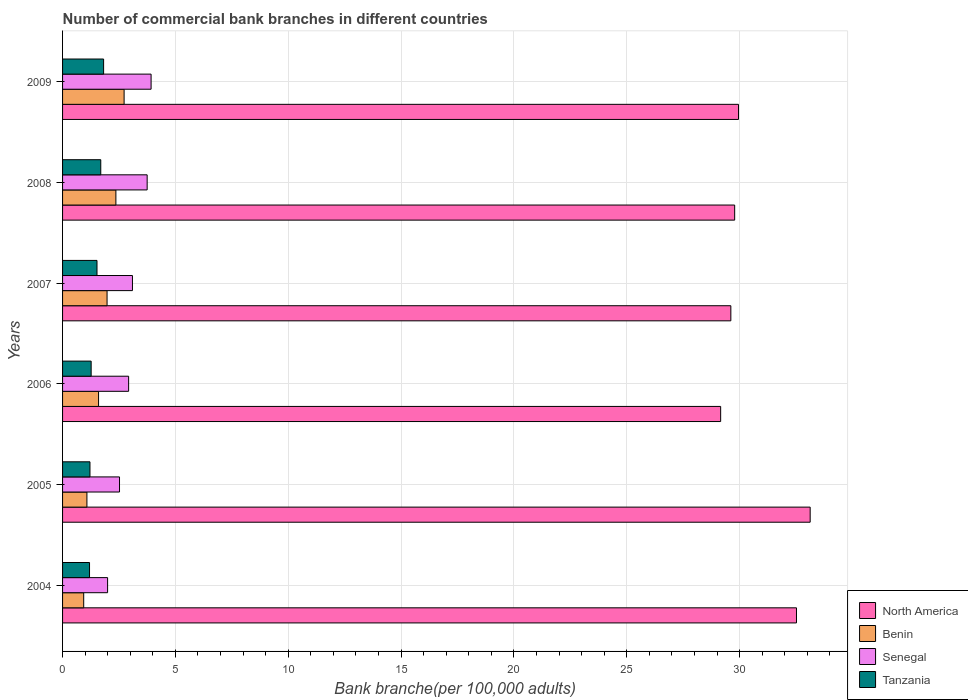Are the number of bars on each tick of the Y-axis equal?
Provide a succinct answer. Yes. How many bars are there on the 4th tick from the top?
Ensure brevity in your answer.  4. How many bars are there on the 3rd tick from the bottom?
Offer a very short reply. 4. What is the label of the 2nd group of bars from the top?
Make the answer very short. 2008. In how many cases, is the number of bars for a given year not equal to the number of legend labels?
Your answer should be very brief. 0. What is the number of commercial bank branches in Tanzania in 2008?
Provide a succinct answer. 1.69. Across all years, what is the maximum number of commercial bank branches in Benin?
Keep it short and to the point. 2.73. Across all years, what is the minimum number of commercial bank branches in Tanzania?
Keep it short and to the point. 1.2. In which year was the number of commercial bank branches in Benin minimum?
Your answer should be very brief. 2004. What is the total number of commercial bank branches in Benin in the graph?
Your answer should be compact. 10.67. What is the difference between the number of commercial bank branches in Benin in 2006 and that in 2009?
Your answer should be compact. -1.13. What is the difference between the number of commercial bank branches in Senegal in 2005 and the number of commercial bank branches in North America in 2008?
Offer a very short reply. -27.26. What is the average number of commercial bank branches in Tanzania per year?
Offer a very short reply. 1.45. In the year 2009, what is the difference between the number of commercial bank branches in Tanzania and number of commercial bank branches in North America?
Your answer should be very brief. -28.13. In how many years, is the number of commercial bank branches in Senegal greater than 12 ?
Provide a short and direct response. 0. What is the ratio of the number of commercial bank branches in Tanzania in 2004 to that in 2008?
Offer a terse response. 0.71. Is the number of commercial bank branches in Benin in 2004 less than that in 2009?
Provide a short and direct response. Yes. What is the difference between the highest and the second highest number of commercial bank branches in North America?
Provide a short and direct response. 0.61. What is the difference between the highest and the lowest number of commercial bank branches in Benin?
Offer a terse response. 1.79. In how many years, is the number of commercial bank branches in Tanzania greater than the average number of commercial bank branches in Tanzania taken over all years?
Provide a succinct answer. 3. Is the sum of the number of commercial bank branches in Benin in 2006 and 2007 greater than the maximum number of commercial bank branches in Tanzania across all years?
Make the answer very short. Yes. What does the 1st bar from the top in 2005 represents?
Keep it short and to the point. Tanzania. What does the 2nd bar from the bottom in 2004 represents?
Give a very brief answer. Benin. Is it the case that in every year, the sum of the number of commercial bank branches in Senegal and number of commercial bank branches in Tanzania is greater than the number of commercial bank branches in Benin?
Make the answer very short. Yes. Are all the bars in the graph horizontal?
Make the answer very short. Yes. Are the values on the major ticks of X-axis written in scientific E-notation?
Provide a succinct answer. No. Does the graph contain grids?
Ensure brevity in your answer.  Yes. Where does the legend appear in the graph?
Your response must be concise. Bottom right. How many legend labels are there?
Give a very brief answer. 4. What is the title of the graph?
Make the answer very short. Number of commercial bank branches in different countries. Does "Comoros" appear as one of the legend labels in the graph?
Your answer should be compact. No. What is the label or title of the X-axis?
Provide a short and direct response. Bank branche(per 100,0 adults). What is the Bank branche(per 100,000 adults) in North America in 2004?
Provide a succinct answer. 32.52. What is the Bank branche(per 100,000 adults) of Benin in 2004?
Offer a very short reply. 0.94. What is the Bank branche(per 100,000 adults) in Senegal in 2004?
Your response must be concise. 2. What is the Bank branche(per 100,000 adults) of Tanzania in 2004?
Your answer should be very brief. 1.2. What is the Bank branche(per 100,000 adults) of North America in 2005?
Your answer should be compact. 33.13. What is the Bank branche(per 100,000 adults) in Benin in 2005?
Your response must be concise. 1.08. What is the Bank branche(per 100,000 adults) of Senegal in 2005?
Your response must be concise. 2.52. What is the Bank branche(per 100,000 adults) in Tanzania in 2005?
Provide a succinct answer. 1.21. What is the Bank branche(per 100,000 adults) of North America in 2006?
Your answer should be compact. 29.16. What is the Bank branche(per 100,000 adults) of Benin in 2006?
Ensure brevity in your answer.  1.59. What is the Bank branche(per 100,000 adults) of Senegal in 2006?
Make the answer very short. 2.93. What is the Bank branche(per 100,000 adults) in Tanzania in 2006?
Provide a succinct answer. 1.27. What is the Bank branche(per 100,000 adults) in North America in 2007?
Your response must be concise. 29.61. What is the Bank branche(per 100,000 adults) of Benin in 2007?
Offer a terse response. 1.97. What is the Bank branche(per 100,000 adults) in Senegal in 2007?
Ensure brevity in your answer.  3.1. What is the Bank branche(per 100,000 adults) in Tanzania in 2007?
Provide a short and direct response. 1.53. What is the Bank branche(per 100,000 adults) of North America in 2008?
Your answer should be very brief. 29.78. What is the Bank branche(per 100,000 adults) of Benin in 2008?
Your answer should be very brief. 2.36. What is the Bank branche(per 100,000 adults) of Senegal in 2008?
Make the answer very short. 3.75. What is the Bank branche(per 100,000 adults) of Tanzania in 2008?
Offer a very short reply. 1.69. What is the Bank branche(per 100,000 adults) in North America in 2009?
Offer a terse response. 29.95. What is the Bank branche(per 100,000 adults) in Benin in 2009?
Offer a terse response. 2.73. What is the Bank branche(per 100,000 adults) in Senegal in 2009?
Your answer should be very brief. 3.92. What is the Bank branche(per 100,000 adults) of Tanzania in 2009?
Keep it short and to the point. 1.82. Across all years, what is the maximum Bank branche(per 100,000 adults) in North America?
Offer a very short reply. 33.13. Across all years, what is the maximum Bank branche(per 100,000 adults) in Benin?
Give a very brief answer. 2.73. Across all years, what is the maximum Bank branche(per 100,000 adults) in Senegal?
Your answer should be compact. 3.92. Across all years, what is the maximum Bank branche(per 100,000 adults) of Tanzania?
Your response must be concise. 1.82. Across all years, what is the minimum Bank branche(per 100,000 adults) of North America?
Your response must be concise. 29.16. Across all years, what is the minimum Bank branche(per 100,000 adults) of Benin?
Your response must be concise. 0.94. Across all years, what is the minimum Bank branche(per 100,000 adults) of Senegal?
Offer a terse response. 2. Across all years, what is the minimum Bank branche(per 100,000 adults) of Tanzania?
Your response must be concise. 1.2. What is the total Bank branche(per 100,000 adults) in North America in the graph?
Keep it short and to the point. 184.16. What is the total Bank branche(per 100,000 adults) in Benin in the graph?
Your response must be concise. 10.67. What is the total Bank branche(per 100,000 adults) in Senegal in the graph?
Ensure brevity in your answer.  18.21. What is the total Bank branche(per 100,000 adults) in Tanzania in the graph?
Your answer should be very brief. 8.71. What is the difference between the Bank branche(per 100,000 adults) in North America in 2004 and that in 2005?
Provide a succinct answer. -0.61. What is the difference between the Bank branche(per 100,000 adults) of Benin in 2004 and that in 2005?
Your response must be concise. -0.14. What is the difference between the Bank branche(per 100,000 adults) of Senegal in 2004 and that in 2005?
Your answer should be very brief. -0.53. What is the difference between the Bank branche(per 100,000 adults) in Tanzania in 2004 and that in 2005?
Your answer should be very brief. -0.02. What is the difference between the Bank branche(per 100,000 adults) in North America in 2004 and that in 2006?
Your answer should be compact. 3.36. What is the difference between the Bank branche(per 100,000 adults) of Benin in 2004 and that in 2006?
Give a very brief answer. -0.66. What is the difference between the Bank branche(per 100,000 adults) in Senegal in 2004 and that in 2006?
Ensure brevity in your answer.  -0.93. What is the difference between the Bank branche(per 100,000 adults) in Tanzania in 2004 and that in 2006?
Offer a terse response. -0.07. What is the difference between the Bank branche(per 100,000 adults) of North America in 2004 and that in 2007?
Your response must be concise. 2.91. What is the difference between the Bank branche(per 100,000 adults) in Benin in 2004 and that in 2007?
Provide a short and direct response. -1.04. What is the difference between the Bank branche(per 100,000 adults) of Senegal in 2004 and that in 2007?
Offer a very short reply. -1.1. What is the difference between the Bank branche(per 100,000 adults) of Tanzania in 2004 and that in 2007?
Your answer should be very brief. -0.33. What is the difference between the Bank branche(per 100,000 adults) in North America in 2004 and that in 2008?
Make the answer very short. 2.74. What is the difference between the Bank branche(per 100,000 adults) of Benin in 2004 and that in 2008?
Provide a succinct answer. -1.43. What is the difference between the Bank branche(per 100,000 adults) of Senegal in 2004 and that in 2008?
Offer a terse response. -1.75. What is the difference between the Bank branche(per 100,000 adults) in Tanzania in 2004 and that in 2008?
Your response must be concise. -0.5. What is the difference between the Bank branche(per 100,000 adults) in North America in 2004 and that in 2009?
Offer a terse response. 2.57. What is the difference between the Bank branche(per 100,000 adults) of Benin in 2004 and that in 2009?
Offer a very short reply. -1.79. What is the difference between the Bank branche(per 100,000 adults) of Senegal in 2004 and that in 2009?
Your answer should be compact. -1.93. What is the difference between the Bank branche(per 100,000 adults) of Tanzania in 2004 and that in 2009?
Offer a terse response. -0.62. What is the difference between the Bank branche(per 100,000 adults) in North America in 2005 and that in 2006?
Your answer should be very brief. 3.97. What is the difference between the Bank branche(per 100,000 adults) of Benin in 2005 and that in 2006?
Provide a succinct answer. -0.52. What is the difference between the Bank branche(per 100,000 adults) in Senegal in 2005 and that in 2006?
Offer a terse response. -0.4. What is the difference between the Bank branche(per 100,000 adults) of Tanzania in 2005 and that in 2006?
Ensure brevity in your answer.  -0.05. What is the difference between the Bank branche(per 100,000 adults) in North America in 2005 and that in 2007?
Your answer should be very brief. 3.52. What is the difference between the Bank branche(per 100,000 adults) in Benin in 2005 and that in 2007?
Give a very brief answer. -0.89. What is the difference between the Bank branche(per 100,000 adults) of Senegal in 2005 and that in 2007?
Your answer should be compact. -0.57. What is the difference between the Bank branche(per 100,000 adults) of Tanzania in 2005 and that in 2007?
Make the answer very short. -0.31. What is the difference between the Bank branche(per 100,000 adults) of North America in 2005 and that in 2008?
Ensure brevity in your answer.  3.35. What is the difference between the Bank branche(per 100,000 adults) in Benin in 2005 and that in 2008?
Keep it short and to the point. -1.28. What is the difference between the Bank branche(per 100,000 adults) of Senegal in 2005 and that in 2008?
Give a very brief answer. -1.23. What is the difference between the Bank branche(per 100,000 adults) in Tanzania in 2005 and that in 2008?
Your answer should be very brief. -0.48. What is the difference between the Bank branche(per 100,000 adults) of North America in 2005 and that in 2009?
Your answer should be very brief. 3.18. What is the difference between the Bank branche(per 100,000 adults) of Benin in 2005 and that in 2009?
Your answer should be very brief. -1.65. What is the difference between the Bank branche(per 100,000 adults) in Senegal in 2005 and that in 2009?
Your answer should be compact. -1.4. What is the difference between the Bank branche(per 100,000 adults) of Tanzania in 2005 and that in 2009?
Offer a very short reply. -0.6. What is the difference between the Bank branche(per 100,000 adults) in North America in 2006 and that in 2007?
Your response must be concise. -0.45. What is the difference between the Bank branche(per 100,000 adults) of Benin in 2006 and that in 2007?
Give a very brief answer. -0.38. What is the difference between the Bank branche(per 100,000 adults) of Senegal in 2006 and that in 2007?
Provide a short and direct response. -0.17. What is the difference between the Bank branche(per 100,000 adults) of Tanzania in 2006 and that in 2007?
Your answer should be compact. -0.26. What is the difference between the Bank branche(per 100,000 adults) of North America in 2006 and that in 2008?
Provide a succinct answer. -0.62. What is the difference between the Bank branche(per 100,000 adults) of Benin in 2006 and that in 2008?
Offer a terse response. -0.77. What is the difference between the Bank branche(per 100,000 adults) in Senegal in 2006 and that in 2008?
Keep it short and to the point. -0.82. What is the difference between the Bank branche(per 100,000 adults) of Tanzania in 2006 and that in 2008?
Keep it short and to the point. -0.43. What is the difference between the Bank branche(per 100,000 adults) in North America in 2006 and that in 2009?
Your answer should be very brief. -0.79. What is the difference between the Bank branche(per 100,000 adults) of Benin in 2006 and that in 2009?
Give a very brief answer. -1.13. What is the difference between the Bank branche(per 100,000 adults) in Senegal in 2006 and that in 2009?
Offer a terse response. -1. What is the difference between the Bank branche(per 100,000 adults) in Tanzania in 2006 and that in 2009?
Make the answer very short. -0.55. What is the difference between the Bank branche(per 100,000 adults) of North America in 2007 and that in 2008?
Give a very brief answer. -0.17. What is the difference between the Bank branche(per 100,000 adults) in Benin in 2007 and that in 2008?
Offer a very short reply. -0.39. What is the difference between the Bank branche(per 100,000 adults) in Senegal in 2007 and that in 2008?
Offer a terse response. -0.65. What is the difference between the Bank branche(per 100,000 adults) in Tanzania in 2007 and that in 2008?
Ensure brevity in your answer.  -0.17. What is the difference between the Bank branche(per 100,000 adults) in North America in 2007 and that in 2009?
Make the answer very short. -0.34. What is the difference between the Bank branche(per 100,000 adults) of Benin in 2007 and that in 2009?
Provide a succinct answer. -0.76. What is the difference between the Bank branche(per 100,000 adults) in Senegal in 2007 and that in 2009?
Keep it short and to the point. -0.83. What is the difference between the Bank branche(per 100,000 adults) of Tanzania in 2007 and that in 2009?
Your answer should be very brief. -0.29. What is the difference between the Bank branche(per 100,000 adults) of North America in 2008 and that in 2009?
Offer a very short reply. -0.17. What is the difference between the Bank branche(per 100,000 adults) of Benin in 2008 and that in 2009?
Make the answer very short. -0.36. What is the difference between the Bank branche(per 100,000 adults) in Senegal in 2008 and that in 2009?
Make the answer very short. -0.17. What is the difference between the Bank branche(per 100,000 adults) of Tanzania in 2008 and that in 2009?
Your answer should be very brief. -0.13. What is the difference between the Bank branche(per 100,000 adults) in North America in 2004 and the Bank branche(per 100,000 adults) in Benin in 2005?
Your answer should be compact. 31.44. What is the difference between the Bank branche(per 100,000 adults) in North America in 2004 and the Bank branche(per 100,000 adults) in Senegal in 2005?
Your answer should be compact. 30. What is the difference between the Bank branche(per 100,000 adults) of North America in 2004 and the Bank branche(per 100,000 adults) of Tanzania in 2005?
Keep it short and to the point. 31.31. What is the difference between the Bank branche(per 100,000 adults) in Benin in 2004 and the Bank branche(per 100,000 adults) in Senegal in 2005?
Give a very brief answer. -1.59. What is the difference between the Bank branche(per 100,000 adults) of Benin in 2004 and the Bank branche(per 100,000 adults) of Tanzania in 2005?
Provide a short and direct response. -0.28. What is the difference between the Bank branche(per 100,000 adults) in Senegal in 2004 and the Bank branche(per 100,000 adults) in Tanzania in 2005?
Your response must be concise. 0.78. What is the difference between the Bank branche(per 100,000 adults) of North America in 2004 and the Bank branche(per 100,000 adults) of Benin in 2006?
Keep it short and to the point. 30.93. What is the difference between the Bank branche(per 100,000 adults) in North America in 2004 and the Bank branche(per 100,000 adults) in Senegal in 2006?
Provide a short and direct response. 29.59. What is the difference between the Bank branche(per 100,000 adults) in North America in 2004 and the Bank branche(per 100,000 adults) in Tanzania in 2006?
Give a very brief answer. 31.25. What is the difference between the Bank branche(per 100,000 adults) in Benin in 2004 and the Bank branche(per 100,000 adults) in Senegal in 2006?
Keep it short and to the point. -1.99. What is the difference between the Bank branche(per 100,000 adults) of Benin in 2004 and the Bank branche(per 100,000 adults) of Tanzania in 2006?
Keep it short and to the point. -0.33. What is the difference between the Bank branche(per 100,000 adults) of Senegal in 2004 and the Bank branche(per 100,000 adults) of Tanzania in 2006?
Give a very brief answer. 0.73. What is the difference between the Bank branche(per 100,000 adults) of North America in 2004 and the Bank branche(per 100,000 adults) of Benin in 2007?
Make the answer very short. 30.55. What is the difference between the Bank branche(per 100,000 adults) in North America in 2004 and the Bank branche(per 100,000 adults) in Senegal in 2007?
Offer a terse response. 29.42. What is the difference between the Bank branche(per 100,000 adults) in North America in 2004 and the Bank branche(per 100,000 adults) in Tanzania in 2007?
Ensure brevity in your answer.  31. What is the difference between the Bank branche(per 100,000 adults) of Benin in 2004 and the Bank branche(per 100,000 adults) of Senegal in 2007?
Ensure brevity in your answer.  -2.16. What is the difference between the Bank branche(per 100,000 adults) of Benin in 2004 and the Bank branche(per 100,000 adults) of Tanzania in 2007?
Give a very brief answer. -0.59. What is the difference between the Bank branche(per 100,000 adults) of Senegal in 2004 and the Bank branche(per 100,000 adults) of Tanzania in 2007?
Your answer should be very brief. 0.47. What is the difference between the Bank branche(per 100,000 adults) in North America in 2004 and the Bank branche(per 100,000 adults) in Benin in 2008?
Keep it short and to the point. 30.16. What is the difference between the Bank branche(per 100,000 adults) in North America in 2004 and the Bank branche(per 100,000 adults) in Senegal in 2008?
Keep it short and to the point. 28.77. What is the difference between the Bank branche(per 100,000 adults) in North America in 2004 and the Bank branche(per 100,000 adults) in Tanzania in 2008?
Your response must be concise. 30.83. What is the difference between the Bank branche(per 100,000 adults) of Benin in 2004 and the Bank branche(per 100,000 adults) of Senegal in 2008?
Provide a succinct answer. -2.81. What is the difference between the Bank branche(per 100,000 adults) in Benin in 2004 and the Bank branche(per 100,000 adults) in Tanzania in 2008?
Keep it short and to the point. -0.76. What is the difference between the Bank branche(per 100,000 adults) in Senegal in 2004 and the Bank branche(per 100,000 adults) in Tanzania in 2008?
Offer a very short reply. 0.3. What is the difference between the Bank branche(per 100,000 adults) in North America in 2004 and the Bank branche(per 100,000 adults) in Benin in 2009?
Provide a short and direct response. 29.79. What is the difference between the Bank branche(per 100,000 adults) of North America in 2004 and the Bank branche(per 100,000 adults) of Senegal in 2009?
Make the answer very short. 28.6. What is the difference between the Bank branche(per 100,000 adults) of North America in 2004 and the Bank branche(per 100,000 adults) of Tanzania in 2009?
Your response must be concise. 30.7. What is the difference between the Bank branche(per 100,000 adults) in Benin in 2004 and the Bank branche(per 100,000 adults) in Senegal in 2009?
Your answer should be very brief. -2.99. What is the difference between the Bank branche(per 100,000 adults) of Benin in 2004 and the Bank branche(per 100,000 adults) of Tanzania in 2009?
Provide a succinct answer. -0.88. What is the difference between the Bank branche(per 100,000 adults) in Senegal in 2004 and the Bank branche(per 100,000 adults) in Tanzania in 2009?
Your answer should be compact. 0.18. What is the difference between the Bank branche(per 100,000 adults) of North America in 2005 and the Bank branche(per 100,000 adults) of Benin in 2006?
Offer a terse response. 31.53. What is the difference between the Bank branche(per 100,000 adults) in North America in 2005 and the Bank branche(per 100,000 adults) in Senegal in 2006?
Your answer should be compact. 30.2. What is the difference between the Bank branche(per 100,000 adults) in North America in 2005 and the Bank branche(per 100,000 adults) in Tanzania in 2006?
Provide a succinct answer. 31.86. What is the difference between the Bank branche(per 100,000 adults) in Benin in 2005 and the Bank branche(per 100,000 adults) in Senegal in 2006?
Your answer should be very brief. -1.85. What is the difference between the Bank branche(per 100,000 adults) of Benin in 2005 and the Bank branche(per 100,000 adults) of Tanzania in 2006?
Offer a very short reply. -0.19. What is the difference between the Bank branche(per 100,000 adults) in Senegal in 2005 and the Bank branche(per 100,000 adults) in Tanzania in 2006?
Ensure brevity in your answer.  1.26. What is the difference between the Bank branche(per 100,000 adults) in North America in 2005 and the Bank branche(per 100,000 adults) in Benin in 2007?
Keep it short and to the point. 31.16. What is the difference between the Bank branche(per 100,000 adults) of North America in 2005 and the Bank branche(per 100,000 adults) of Senegal in 2007?
Your answer should be very brief. 30.03. What is the difference between the Bank branche(per 100,000 adults) in North America in 2005 and the Bank branche(per 100,000 adults) in Tanzania in 2007?
Offer a terse response. 31.6. What is the difference between the Bank branche(per 100,000 adults) in Benin in 2005 and the Bank branche(per 100,000 adults) in Senegal in 2007?
Give a very brief answer. -2.02. What is the difference between the Bank branche(per 100,000 adults) of Benin in 2005 and the Bank branche(per 100,000 adults) of Tanzania in 2007?
Give a very brief answer. -0.45. What is the difference between the Bank branche(per 100,000 adults) in Senegal in 2005 and the Bank branche(per 100,000 adults) in Tanzania in 2007?
Keep it short and to the point. 1. What is the difference between the Bank branche(per 100,000 adults) in North America in 2005 and the Bank branche(per 100,000 adults) in Benin in 2008?
Provide a succinct answer. 30.77. What is the difference between the Bank branche(per 100,000 adults) in North America in 2005 and the Bank branche(per 100,000 adults) in Senegal in 2008?
Ensure brevity in your answer.  29.38. What is the difference between the Bank branche(per 100,000 adults) in North America in 2005 and the Bank branche(per 100,000 adults) in Tanzania in 2008?
Make the answer very short. 31.44. What is the difference between the Bank branche(per 100,000 adults) in Benin in 2005 and the Bank branche(per 100,000 adults) in Senegal in 2008?
Your response must be concise. -2.67. What is the difference between the Bank branche(per 100,000 adults) of Benin in 2005 and the Bank branche(per 100,000 adults) of Tanzania in 2008?
Provide a short and direct response. -0.61. What is the difference between the Bank branche(per 100,000 adults) in Senegal in 2005 and the Bank branche(per 100,000 adults) in Tanzania in 2008?
Your answer should be compact. 0.83. What is the difference between the Bank branche(per 100,000 adults) in North America in 2005 and the Bank branche(per 100,000 adults) in Benin in 2009?
Provide a succinct answer. 30.4. What is the difference between the Bank branche(per 100,000 adults) of North America in 2005 and the Bank branche(per 100,000 adults) of Senegal in 2009?
Give a very brief answer. 29.21. What is the difference between the Bank branche(per 100,000 adults) in North America in 2005 and the Bank branche(per 100,000 adults) in Tanzania in 2009?
Keep it short and to the point. 31.31. What is the difference between the Bank branche(per 100,000 adults) in Benin in 2005 and the Bank branche(per 100,000 adults) in Senegal in 2009?
Your answer should be very brief. -2.84. What is the difference between the Bank branche(per 100,000 adults) in Benin in 2005 and the Bank branche(per 100,000 adults) in Tanzania in 2009?
Keep it short and to the point. -0.74. What is the difference between the Bank branche(per 100,000 adults) in Senegal in 2005 and the Bank branche(per 100,000 adults) in Tanzania in 2009?
Your answer should be very brief. 0.7. What is the difference between the Bank branche(per 100,000 adults) in North America in 2006 and the Bank branche(per 100,000 adults) in Benin in 2007?
Your answer should be very brief. 27.19. What is the difference between the Bank branche(per 100,000 adults) in North America in 2006 and the Bank branche(per 100,000 adults) in Senegal in 2007?
Offer a terse response. 26.07. What is the difference between the Bank branche(per 100,000 adults) in North America in 2006 and the Bank branche(per 100,000 adults) in Tanzania in 2007?
Your response must be concise. 27.64. What is the difference between the Bank branche(per 100,000 adults) in Benin in 2006 and the Bank branche(per 100,000 adults) in Senegal in 2007?
Make the answer very short. -1.5. What is the difference between the Bank branche(per 100,000 adults) in Benin in 2006 and the Bank branche(per 100,000 adults) in Tanzania in 2007?
Ensure brevity in your answer.  0.07. What is the difference between the Bank branche(per 100,000 adults) in Senegal in 2006 and the Bank branche(per 100,000 adults) in Tanzania in 2007?
Make the answer very short. 1.4. What is the difference between the Bank branche(per 100,000 adults) of North America in 2006 and the Bank branche(per 100,000 adults) of Benin in 2008?
Ensure brevity in your answer.  26.8. What is the difference between the Bank branche(per 100,000 adults) of North America in 2006 and the Bank branche(per 100,000 adults) of Senegal in 2008?
Offer a terse response. 25.41. What is the difference between the Bank branche(per 100,000 adults) in North America in 2006 and the Bank branche(per 100,000 adults) in Tanzania in 2008?
Ensure brevity in your answer.  27.47. What is the difference between the Bank branche(per 100,000 adults) in Benin in 2006 and the Bank branche(per 100,000 adults) in Senegal in 2008?
Keep it short and to the point. -2.15. What is the difference between the Bank branche(per 100,000 adults) in Benin in 2006 and the Bank branche(per 100,000 adults) in Tanzania in 2008?
Your response must be concise. -0.1. What is the difference between the Bank branche(per 100,000 adults) in Senegal in 2006 and the Bank branche(per 100,000 adults) in Tanzania in 2008?
Your response must be concise. 1.23. What is the difference between the Bank branche(per 100,000 adults) in North America in 2006 and the Bank branche(per 100,000 adults) in Benin in 2009?
Provide a short and direct response. 26.43. What is the difference between the Bank branche(per 100,000 adults) in North America in 2006 and the Bank branche(per 100,000 adults) in Senegal in 2009?
Ensure brevity in your answer.  25.24. What is the difference between the Bank branche(per 100,000 adults) of North America in 2006 and the Bank branche(per 100,000 adults) of Tanzania in 2009?
Provide a short and direct response. 27.34. What is the difference between the Bank branche(per 100,000 adults) in Benin in 2006 and the Bank branche(per 100,000 adults) in Senegal in 2009?
Your answer should be compact. -2.33. What is the difference between the Bank branche(per 100,000 adults) of Benin in 2006 and the Bank branche(per 100,000 adults) of Tanzania in 2009?
Offer a very short reply. -0.22. What is the difference between the Bank branche(per 100,000 adults) in Senegal in 2006 and the Bank branche(per 100,000 adults) in Tanzania in 2009?
Give a very brief answer. 1.11. What is the difference between the Bank branche(per 100,000 adults) in North America in 2007 and the Bank branche(per 100,000 adults) in Benin in 2008?
Offer a terse response. 27.25. What is the difference between the Bank branche(per 100,000 adults) in North America in 2007 and the Bank branche(per 100,000 adults) in Senegal in 2008?
Give a very brief answer. 25.86. What is the difference between the Bank branche(per 100,000 adults) in North America in 2007 and the Bank branche(per 100,000 adults) in Tanzania in 2008?
Offer a very short reply. 27.92. What is the difference between the Bank branche(per 100,000 adults) of Benin in 2007 and the Bank branche(per 100,000 adults) of Senegal in 2008?
Your answer should be very brief. -1.78. What is the difference between the Bank branche(per 100,000 adults) in Benin in 2007 and the Bank branche(per 100,000 adults) in Tanzania in 2008?
Keep it short and to the point. 0.28. What is the difference between the Bank branche(per 100,000 adults) in Senegal in 2007 and the Bank branche(per 100,000 adults) in Tanzania in 2008?
Make the answer very short. 1.4. What is the difference between the Bank branche(per 100,000 adults) of North America in 2007 and the Bank branche(per 100,000 adults) of Benin in 2009?
Your response must be concise. 26.89. What is the difference between the Bank branche(per 100,000 adults) of North America in 2007 and the Bank branche(per 100,000 adults) of Senegal in 2009?
Provide a short and direct response. 25.69. What is the difference between the Bank branche(per 100,000 adults) of North America in 2007 and the Bank branche(per 100,000 adults) of Tanzania in 2009?
Offer a terse response. 27.79. What is the difference between the Bank branche(per 100,000 adults) in Benin in 2007 and the Bank branche(per 100,000 adults) in Senegal in 2009?
Make the answer very short. -1.95. What is the difference between the Bank branche(per 100,000 adults) of Benin in 2007 and the Bank branche(per 100,000 adults) of Tanzania in 2009?
Provide a short and direct response. 0.15. What is the difference between the Bank branche(per 100,000 adults) in Senegal in 2007 and the Bank branche(per 100,000 adults) in Tanzania in 2009?
Offer a very short reply. 1.28. What is the difference between the Bank branche(per 100,000 adults) of North America in 2008 and the Bank branche(per 100,000 adults) of Benin in 2009?
Your answer should be compact. 27.06. What is the difference between the Bank branche(per 100,000 adults) of North America in 2008 and the Bank branche(per 100,000 adults) of Senegal in 2009?
Keep it short and to the point. 25.86. What is the difference between the Bank branche(per 100,000 adults) of North America in 2008 and the Bank branche(per 100,000 adults) of Tanzania in 2009?
Your answer should be compact. 27.96. What is the difference between the Bank branche(per 100,000 adults) in Benin in 2008 and the Bank branche(per 100,000 adults) in Senegal in 2009?
Give a very brief answer. -1.56. What is the difference between the Bank branche(per 100,000 adults) in Benin in 2008 and the Bank branche(per 100,000 adults) in Tanzania in 2009?
Provide a succinct answer. 0.54. What is the difference between the Bank branche(per 100,000 adults) in Senegal in 2008 and the Bank branche(per 100,000 adults) in Tanzania in 2009?
Make the answer very short. 1.93. What is the average Bank branche(per 100,000 adults) of North America per year?
Your response must be concise. 30.69. What is the average Bank branche(per 100,000 adults) of Benin per year?
Ensure brevity in your answer.  1.78. What is the average Bank branche(per 100,000 adults) of Senegal per year?
Keep it short and to the point. 3.04. What is the average Bank branche(per 100,000 adults) in Tanzania per year?
Give a very brief answer. 1.45. In the year 2004, what is the difference between the Bank branche(per 100,000 adults) of North America and Bank branche(per 100,000 adults) of Benin?
Make the answer very short. 31.59. In the year 2004, what is the difference between the Bank branche(per 100,000 adults) of North America and Bank branche(per 100,000 adults) of Senegal?
Keep it short and to the point. 30.53. In the year 2004, what is the difference between the Bank branche(per 100,000 adults) of North America and Bank branche(per 100,000 adults) of Tanzania?
Give a very brief answer. 31.33. In the year 2004, what is the difference between the Bank branche(per 100,000 adults) of Benin and Bank branche(per 100,000 adults) of Senegal?
Your answer should be compact. -1.06. In the year 2004, what is the difference between the Bank branche(per 100,000 adults) of Benin and Bank branche(per 100,000 adults) of Tanzania?
Your answer should be compact. -0.26. In the year 2004, what is the difference between the Bank branche(per 100,000 adults) in Senegal and Bank branche(per 100,000 adults) in Tanzania?
Offer a terse response. 0.8. In the year 2005, what is the difference between the Bank branche(per 100,000 adults) in North America and Bank branche(per 100,000 adults) in Benin?
Offer a very short reply. 32.05. In the year 2005, what is the difference between the Bank branche(per 100,000 adults) in North America and Bank branche(per 100,000 adults) in Senegal?
Your response must be concise. 30.6. In the year 2005, what is the difference between the Bank branche(per 100,000 adults) in North America and Bank branche(per 100,000 adults) in Tanzania?
Make the answer very short. 31.91. In the year 2005, what is the difference between the Bank branche(per 100,000 adults) of Benin and Bank branche(per 100,000 adults) of Senegal?
Your answer should be very brief. -1.44. In the year 2005, what is the difference between the Bank branche(per 100,000 adults) of Benin and Bank branche(per 100,000 adults) of Tanzania?
Provide a succinct answer. -0.13. In the year 2005, what is the difference between the Bank branche(per 100,000 adults) in Senegal and Bank branche(per 100,000 adults) in Tanzania?
Offer a terse response. 1.31. In the year 2006, what is the difference between the Bank branche(per 100,000 adults) of North America and Bank branche(per 100,000 adults) of Benin?
Your answer should be very brief. 27.57. In the year 2006, what is the difference between the Bank branche(per 100,000 adults) of North America and Bank branche(per 100,000 adults) of Senegal?
Your answer should be compact. 26.23. In the year 2006, what is the difference between the Bank branche(per 100,000 adults) in North America and Bank branche(per 100,000 adults) in Tanzania?
Offer a very short reply. 27.9. In the year 2006, what is the difference between the Bank branche(per 100,000 adults) of Benin and Bank branche(per 100,000 adults) of Senegal?
Offer a terse response. -1.33. In the year 2006, what is the difference between the Bank branche(per 100,000 adults) of Benin and Bank branche(per 100,000 adults) of Tanzania?
Provide a succinct answer. 0.33. In the year 2006, what is the difference between the Bank branche(per 100,000 adults) in Senegal and Bank branche(per 100,000 adults) in Tanzania?
Provide a short and direct response. 1.66. In the year 2007, what is the difference between the Bank branche(per 100,000 adults) in North America and Bank branche(per 100,000 adults) in Benin?
Give a very brief answer. 27.64. In the year 2007, what is the difference between the Bank branche(per 100,000 adults) of North America and Bank branche(per 100,000 adults) of Senegal?
Offer a very short reply. 26.52. In the year 2007, what is the difference between the Bank branche(per 100,000 adults) of North America and Bank branche(per 100,000 adults) of Tanzania?
Your answer should be compact. 28.09. In the year 2007, what is the difference between the Bank branche(per 100,000 adults) of Benin and Bank branche(per 100,000 adults) of Senegal?
Provide a succinct answer. -1.12. In the year 2007, what is the difference between the Bank branche(per 100,000 adults) of Benin and Bank branche(per 100,000 adults) of Tanzania?
Keep it short and to the point. 0.45. In the year 2007, what is the difference between the Bank branche(per 100,000 adults) of Senegal and Bank branche(per 100,000 adults) of Tanzania?
Offer a very short reply. 1.57. In the year 2008, what is the difference between the Bank branche(per 100,000 adults) of North America and Bank branche(per 100,000 adults) of Benin?
Your answer should be very brief. 27.42. In the year 2008, what is the difference between the Bank branche(per 100,000 adults) in North America and Bank branche(per 100,000 adults) in Senegal?
Make the answer very short. 26.03. In the year 2008, what is the difference between the Bank branche(per 100,000 adults) in North America and Bank branche(per 100,000 adults) in Tanzania?
Keep it short and to the point. 28.09. In the year 2008, what is the difference between the Bank branche(per 100,000 adults) in Benin and Bank branche(per 100,000 adults) in Senegal?
Provide a succinct answer. -1.39. In the year 2008, what is the difference between the Bank branche(per 100,000 adults) in Benin and Bank branche(per 100,000 adults) in Tanzania?
Offer a terse response. 0.67. In the year 2008, what is the difference between the Bank branche(per 100,000 adults) of Senegal and Bank branche(per 100,000 adults) of Tanzania?
Make the answer very short. 2.06. In the year 2009, what is the difference between the Bank branche(per 100,000 adults) of North America and Bank branche(per 100,000 adults) of Benin?
Make the answer very short. 27.23. In the year 2009, what is the difference between the Bank branche(per 100,000 adults) of North America and Bank branche(per 100,000 adults) of Senegal?
Your answer should be very brief. 26.03. In the year 2009, what is the difference between the Bank branche(per 100,000 adults) of North America and Bank branche(per 100,000 adults) of Tanzania?
Make the answer very short. 28.13. In the year 2009, what is the difference between the Bank branche(per 100,000 adults) of Benin and Bank branche(per 100,000 adults) of Senegal?
Offer a terse response. -1.2. In the year 2009, what is the difference between the Bank branche(per 100,000 adults) in Benin and Bank branche(per 100,000 adults) in Tanzania?
Ensure brevity in your answer.  0.91. In the year 2009, what is the difference between the Bank branche(per 100,000 adults) in Senegal and Bank branche(per 100,000 adults) in Tanzania?
Your answer should be very brief. 2.1. What is the ratio of the Bank branche(per 100,000 adults) in North America in 2004 to that in 2005?
Offer a terse response. 0.98. What is the ratio of the Bank branche(per 100,000 adults) of Benin in 2004 to that in 2005?
Give a very brief answer. 0.87. What is the ratio of the Bank branche(per 100,000 adults) in Senegal in 2004 to that in 2005?
Give a very brief answer. 0.79. What is the ratio of the Bank branche(per 100,000 adults) of Tanzania in 2004 to that in 2005?
Provide a short and direct response. 0.98. What is the ratio of the Bank branche(per 100,000 adults) in North America in 2004 to that in 2006?
Make the answer very short. 1.12. What is the ratio of the Bank branche(per 100,000 adults) of Benin in 2004 to that in 2006?
Make the answer very short. 0.59. What is the ratio of the Bank branche(per 100,000 adults) of Senegal in 2004 to that in 2006?
Provide a succinct answer. 0.68. What is the ratio of the Bank branche(per 100,000 adults) in Tanzania in 2004 to that in 2006?
Give a very brief answer. 0.94. What is the ratio of the Bank branche(per 100,000 adults) in North America in 2004 to that in 2007?
Provide a succinct answer. 1.1. What is the ratio of the Bank branche(per 100,000 adults) in Benin in 2004 to that in 2007?
Give a very brief answer. 0.47. What is the ratio of the Bank branche(per 100,000 adults) of Senegal in 2004 to that in 2007?
Provide a succinct answer. 0.64. What is the ratio of the Bank branche(per 100,000 adults) in Tanzania in 2004 to that in 2007?
Keep it short and to the point. 0.78. What is the ratio of the Bank branche(per 100,000 adults) in North America in 2004 to that in 2008?
Offer a very short reply. 1.09. What is the ratio of the Bank branche(per 100,000 adults) of Benin in 2004 to that in 2008?
Your response must be concise. 0.4. What is the ratio of the Bank branche(per 100,000 adults) of Senegal in 2004 to that in 2008?
Offer a very short reply. 0.53. What is the ratio of the Bank branche(per 100,000 adults) in Tanzania in 2004 to that in 2008?
Provide a short and direct response. 0.71. What is the ratio of the Bank branche(per 100,000 adults) in North America in 2004 to that in 2009?
Offer a very short reply. 1.09. What is the ratio of the Bank branche(per 100,000 adults) of Benin in 2004 to that in 2009?
Your answer should be compact. 0.34. What is the ratio of the Bank branche(per 100,000 adults) of Senegal in 2004 to that in 2009?
Provide a short and direct response. 0.51. What is the ratio of the Bank branche(per 100,000 adults) in Tanzania in 2004 to that in 2009?
Offer a terse response. 0.66. What is the ratio of the Bank branche(per 100,000 adults) of North America in 2005 to that in 2006?
Give a very brief answer. 1.14. What is the ratio of the Bank branche(per 100,000 adults) of Benin in 2005 to that in 2006?
Keep it short and to the point. 0.68. What is the ratio of the Bank branche(per 100,000 adults) of Senegal in 2005 to that in 2006?
Your answer should be compact. 0.86. What is the ratio of the Bank branche(per 100,000 adults) of Tanzania in 2005 to that in 2006?
Your answer should be compact. 0.96. What is the ratio of the Bank branche(per 100,000 adults) in North America in 2005 to that in 2007?
Provide a succinct answer. 1.12. What is the ratio of the Bank branche(per 100,000 adults) in Benin in 2005 to that in 2007?
Make the answer very short. 0.55. What is the ratio of the Bank branche(per 100,000 adults) of Senegal in 2005 to that in 2007?
Give a very brief answer. 0.81. What is the ratio of the Bank branche(per 100,000 adults) of Tanzania in 2005 to that in 2007?
Your answer should be very brief. 0.8. What is the ratio of the Bank branche(per 100,000 adults) in North America in 2005 to that in 2008?
Your response must be concise. 1.11. What is the ratio of the Bank branche(per 100,000 adults) in Benin in 2005 to that in 2008?
Provide a short and direct response. 0.46. What is the ratio of the Bank branche(per 100,000 adults) in Senegal in 2005 to that in 2008?
Make the answer very short. 0.67. What is the ratio of the Bank branche(per 100,000 adults) of Tanzania in 2005 to that in 2008?
Give a very brief answer. 0.72. What is the ratio of the Bank branche(per 100,000 adults) in North America in 2005 to that in 2009?
Provide a succinct answer. 1.11. What is the ratio of the Bank branche(per 100,000 adults) of Benin in 2005 to that in 2009?
Offer a terse response. 0.4. What is the ratio of the Bank branche(per 100,000 adults) of Senegal in 2005 to that in 2009?
Your answer should be compact. 0.64. What is the ratio of the Bank branche(per 100,000 adults) in Tanzania in 2005 to that in 2009?
Keep it short and to the point. 0.67. What is the ratio of the Bank branche(per 100,000 adults) of North America in 2006 to that in 2007?
Ensure brevity in your answer.  0.98. What is the ratio of the Bank branche(per 100,000 adults) of Benin in 2006 to that in 2007?
Your answer should be very brief. 0.81. What is the ratio of the Bank branche(per 100,000 adults) of Senegal in 2006 to that in 2007?
Offer a terse response. 0.95. What is the ratio of the Bank branche(per 100,000 adults) in Tanzania in 2006 to that in 2007?
Provide a short and direct response. 0.83. What is the ratio of the Bank branche(per 100,000 adults) of North America in 2006 to that in 2008?
Your response must be concise. 0.98. What is the ratio of the Bank branche(per 100,000 adults) of Benin in 2006 to that in 2008?
Make the answer very short. 0.68. What is the ratio of the Bank branche(per 100,000 adults) in Senegal in 2006 to that in 2008?
Give a very brief answer. 0.78. What is the ratio of the Bank branche(per 100,000 adults) of Tanzania in 2006 to that in 2008?
Make the answer very short. 0.75. What is the ratio of the Bank branche(per 100,000 adults) of North America in 2006 to that in 2009?
Your answer should be compact. 0.97. What is the ratio of the Bank branche(per 100,000 adults) in Benin in 2006 to that in 2009?
Your response must be concise. 0.58. What is the ratio of the Bank branche(per 100,000 adults) in Senegal in 2006 to that in 2009?
Your response must be concise. 0.75. What is the ratio of the Bank branche(per 100,000 adults) of Tanzania in 2006 to that in 2009?
Your answer should be very brief. 0.7. What is the ratio of the Bank branche(per 100,000 adults) in North America in 2007 to that in 2008?
Provide a short and direct response. 0.99. What is the ratio of the Bank branche(per 100,000 adults) of Benin in 2007 to that in 2008?
Offer a very short reply. 0.83. What is the ratio of the Bank branche(per 100,000 adults) of Senegal in 2007 to that in 2008?
Keep it short and to the point. 0.83. What is the ratio of the Bank branche(per 100,000 adults) of Tanzania in 2007 to that in 2008?
Your answer should be compact. 0.9. What is the ratio of the Bank branche(per 100,000 adults) of North America in 2007 to that in 2009?
Keep it short and to the point. 0.99. What is the ratio of the Bank branche(per 100,000 adults) of Benin in 2007 to that in 2009?
Provide a succinct answer. 0.72. What is the ratio of the Bank branche(per 100,000 adults) of Senegal in 2007 to that in 2009?
Offer a terse response. 0.79. What is the ratio of the Bank branche(per 100,000 adults) in Tanzania in 2007 to that in 2009?
Ensure brevity in your answer.  0.84. What is the ratio of the Bank branche(per 100,000 adults) in North America in 2008 to that in 2009?
Ensure brevity in your answer.  0.99. What is the ratio of the Bank branche(per 100,000 adults) in Benin in 2008 to that in 2009?
Your response must be concise. 0.87. What is the ratio of the Bank branche(per 100,000 adults) of Senegal in 2008 to that in 2009?
Keep it short and to the point. 0.96. What is the ratio of the Bank branche(per 100,000 adults) in Tanzania in 2008 to that in 2009?
Ensure brevity in your answer.  0.93. What is the difference between the highest and the second highest Bank branche(per 100,000 adults) of North America?
Provide a short and direct response. 0.61. What is the difference between the highest and the second highest Bank branche(per 100,000 adults) of Benin?
Keep it short and to the point. 0.36. What is the difference between the highest and the second highest Bank branche(per 100,000 adults) of Senegal?
Give a very brief answer. 0.17. What is the difference between the highest and the second highest Bank branche(per 100,000 adults) of Tanzania?
Ensure brevity in your answer.  0.13. What is the difference between the highest and the lowest Bank branche(per 100,000 adults) of North America?
Your response must be concise. 3.97. What is the difference between the highest and the lowest Bank branche(per 100,000 adults) of Benin?
Your answer should be compact. 1.79. What is the difference between the highest and the lowest Bank branche(per 100,000 adults) in Senegal?
Your response must be concise. 1.93. What is the difference between the highest and the lowest Bank branche(per 100,000 adults) in Tanzania?
Offer a very short reply. 0.62. 